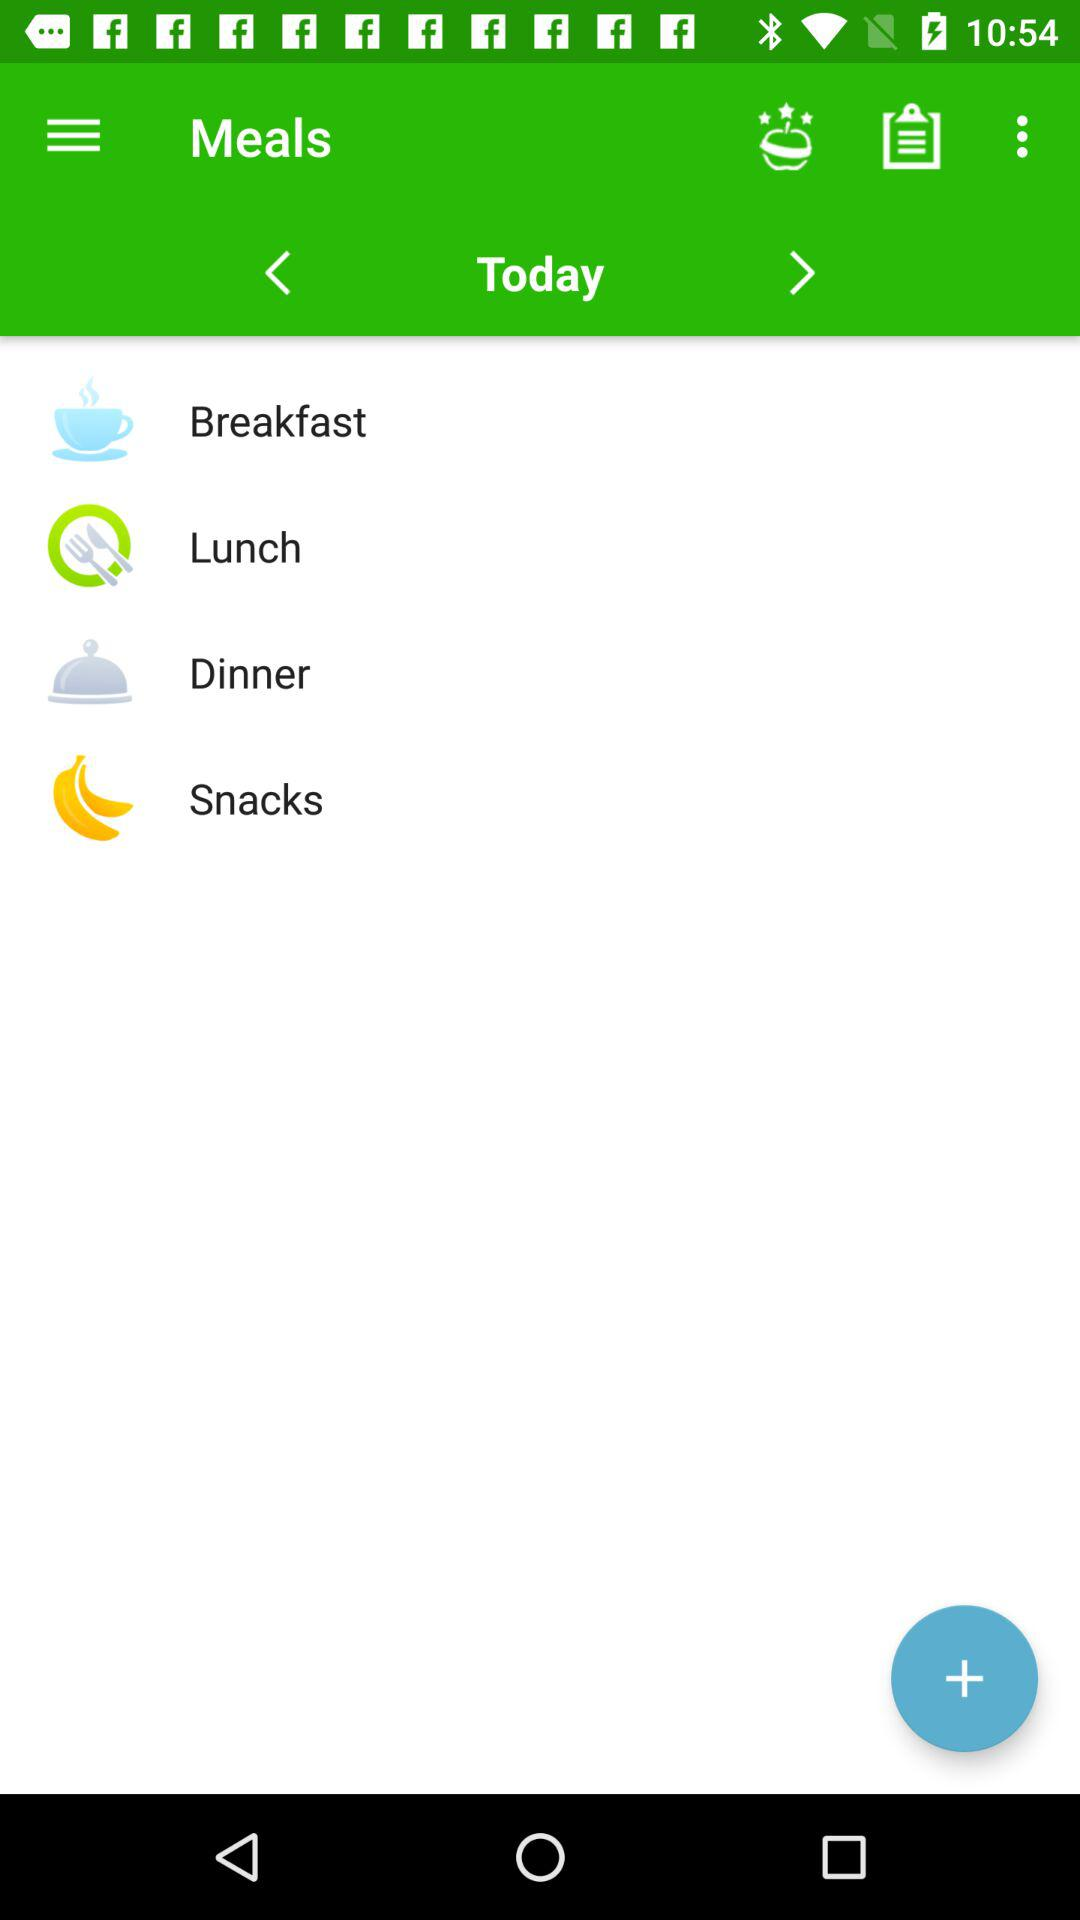What is the given day? The given day is "Today". 